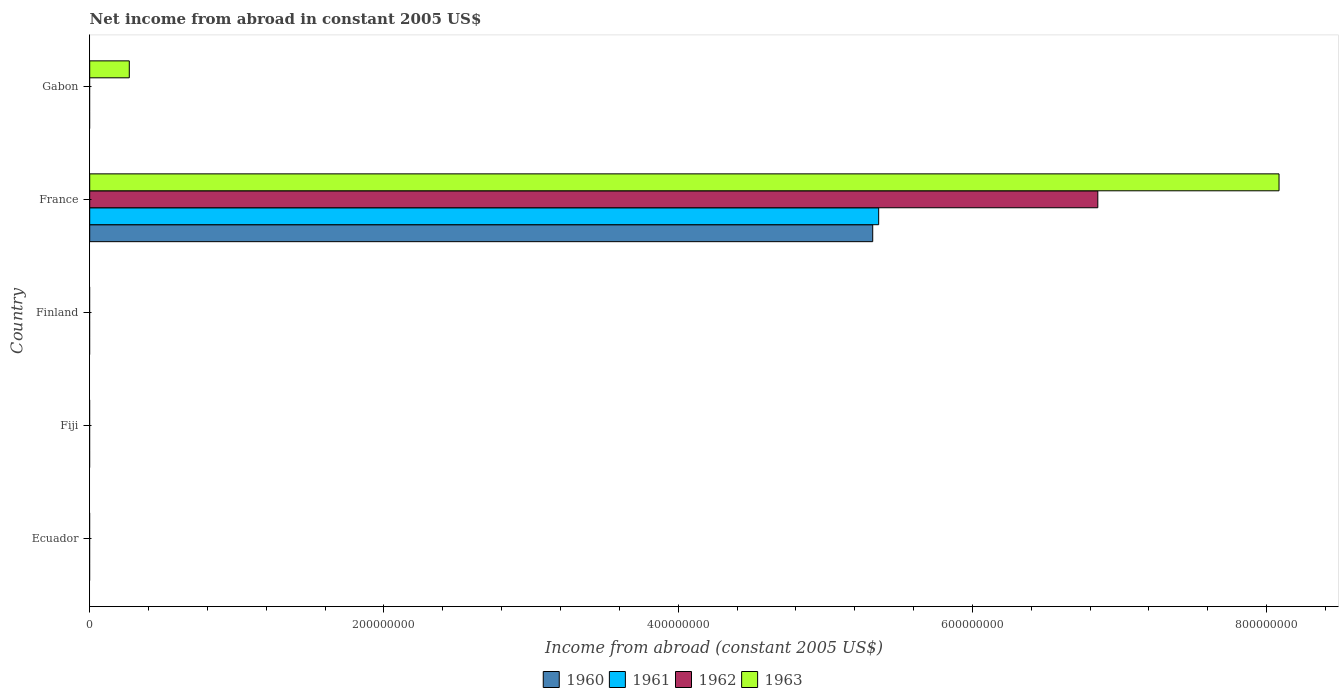How many bars are there on the 1st tick from the top?
Your response must be concise. 1. What is the label of the 4th group of bars from the top?
Your answer should be compact. Fiji. Across all countries, what is the maximum net income from abroad in 1963?
Ensure brevity in your answer.  8.08e+08. What is the total net income from abroad in 1960 in the graph?
Make the answer very short. 5.32e+08. What is the average net income from abroad in 1962 per country?
Offer a terse response. 1.37e+08. What is the difference between the net income from abroad in 1962 and net income from abroad in 1963 in France?
Your response must be concise. -1.23e+08. In how many countries, is the net income from abroad in 1963 greater than 520000000 US$?
Your answer should be compact. 1. What is the ratio of the net income from abroad in 1963 in France to that in Gabon?
Your answer should be compact. 30.04. What is the difference between the highest and the lowest net income from abroad in 1961?
Your answer should be very brief. 5.36e+08. In how many countries, is the net income from abroad in 1961 greater than the average net income from abroad in 1961 taken over all countries?
Give a very brief answer. 1. Is it the case that in every country, the sum of the net income from abroad in 1961 and net income from abroad in 1960 is greater than the sum of net income from abroad in 1962 and net income from abroad in 1963?
Offer a very short reply. No. Is it the case that in every country, the sum of the net income from abroad in 1962 and net income from abroad in 1963 is greater than the net income from abroad in 1960?
Your answer should be very brief. No. What is the difference between two consecutive major ticks on the X-axis?
Your response must be concise. 2.00e+08. Does the graph contain grids?
Offer a very short reply. No. Where does the legend appear in the graph?
Provide a succinct answer. Bottom center. How are the legend labels stacked?
Provide a short and direct response. Horizontal. What is the title of the graph?
Offer a terse response. Net income from abroad in constant 2005 US$. Does "1971" appear as one of the legend labels in the graph?
Your answer should be compact. No. What is the label or title of the X-axis?
Your answer should be compact. Income from abroad (constant 2005 US$). What is the label or title of the Y-axis?
Provide a short and direct response. Country. What is the Income from abroad (constant 2005 US$) of 1960 in Ecuador?
Make the answer very short. 0. What is the Income from abroad (constant 2005 US$) of 1963 in Fiji?
Provide a short and direct response. 0. What is the Income from abroad (constant 2005 US$) of 1960 in Finland?
Your answer should be compact. 0. What is the Income from abroad (constant 2005 US$) in 1961 in Finland?
Ensure brevity in your answer.  0. What is the Income from abroad (constant 2005 US$) of 1962 in Finland?
Give a very brief answer. 0. What is the Income from abroad (constant 2005 US$) in 1963 in Finland?
Provide a succinct answer. 0. What is the Income from abroad (constant 2005 US$) of 1960 in France?
Your answer should be compact. 5.32e+08. What is the Income from abroad (constant 2005 US$) of 1961 in France?
Provide a short and direct response. 5.36e+08. What is the Income from abroad (constant 2005 US$) in 1962 in France?
Offer a terse response. 6.85e+08. What is the Income from abroad (constant 2005 US$) in 1963 in France?
Your answer should be very brief. 8.08e+08. What is the Income from abroad (constant 2005 US$) in 1963 in Gabon?
Keep it short and to the point. 2.69e+07. Across all countries, what is the maximum Income from abroad (constant 2005 US$) in 1960?
Give a very brief answer. 5.32e+08. Across all countries, what is the maximum Income from abroad (constant 2005 US$) of 1961?
Provide a succinct answer. 5.36e+08. Across all countries, what is the maximum Income from abroad (constant 2005 US$) in 1962?
Your answer should be compact. 6.85e+08. Across all countries, what is the maximum Income from abroad (constant 2005 US$) of 1963?
Provide a short and direct response. 8.08e+08. Across all countries, what is the minimum Income from abroad (constant 2005 US$) of 1960?
Provide a succinct answer. 0. Across all countries, what is the minimum Income from abroad (constant 2005 US$) of 1961?
Give a very brief answer. 0. Across all countries, what is the minimum Income from abroad (constant 2005 US$) of 1962?
Provide a succinct answer. 0. What is the total Income from abroad (constant 2005 US$) of 1960 in the graph?
Make the answer very short. 5.32e+08. What is the total Income from abroad (constant 2005 US$) in 1961 in the graph?
Ensure brevity in your answer.  5.36e+08. What is the total Income from abroad (constant 2005 US$) of 1962 in the graph?
Your answer should be very brief. 6.85e+08. What is the total Income from abroad (constant 2005 US$) of 1963 in the graph?
Your answer should be very brief. 8.35e+08. What is the difference between the Income from abroad (constant 2005 US$) of 1963 in France and that in Gabon?
Offer a very short reply. 7.81e+08. What is the difference between the Income from abroad (constant 2005 US$) of 1960 in France and the Income from abroad (constant 2005 US$) of 1963 in Gabon?
Ensure brevity in your answer.  5.05e+08. What is the difference between the Income from abroad (constant 2005 US$) of 1961 in France and the Income from abroad (constant 2005 US$) of 1963 in Gabon?
Your answer should be very brief. 5.09e+08. What is the difference between the Income from abroad (constant 2005 US$) of 1962 in France and the Income from abroad (constant 2005 US$) of 1963 in Gabon?
Make the answer very short. 6.58e+08. What is the average Income from abroad (constant 2005 US$) in 1960 per country?
Offer a terse response. 1.06e+08. What is the average Income from abroad (constant 2005 US$) in 1961 per country?
Your answer should be compact. 1.07e+08. What is the average Income from abroad (constant 2005 US$) in 1962 per country?
Your answer should be very brief. 1.37e+08. What is the average Income from abroad (constant 2005 US$) of 1963 per country?
Your answer should be compact. 1.67e+08. What is the difference between the Income from abroad (constant 2005 US$) in 1960 and Income from abroad (constant 2005 US$) in 1961 in France?
Offer a terse response. -4.05e+06. What is the difference between the Income from abroad (constant 2005 US$) in 1960 and Income from abroad (constant 2005 US$) in 1962 in France?
Ensure brevity in your answer.  -1.53e+08. What is the difference between the Income from abroad (constant 2005 US$) of 1960 and Income from abroad (constant 2005 US$) of 1963 in France?
Provide a short and direct response. -2.76e+08. What is the difference between the Income from abroad (constant 2005 US$) in 1961 and Income from abroad (constant 2005 US$) in 1962 in France?
Keep it short and to the point. -1.49e+08. What is the difference between the Income from abroad (constant 2005 US$) in 1961 and Income from abroad (constant 2005 US$) in 1963 in France?
Offer a terse response. -2.72e+08. What is the difference between the Income from abroad (constant 2005 US$) of 1962 and Income from abroad (constant 2005 US$) of 1963 in France?
Make the answer very short. -1.23e+08. What is the ratio of the Income from abroad (constant 2005 US$) of 1963 in France to that in Gabon?
Offer a terse response. 30.04. What is the difference between the highest and the lowest Income from abroad (constant 2005 US$) of 1960?
Your answer should be very brief. 5.32e+08. What is the difference between the highest and the lowest Income from abroad (constant 2005 US$) in 1961?
Provide a short and direct response. 5.36e+08. What is the difference between the highest and the lowest Income from abroad (constant 2005 US$) in 1962?
Your answer should be compact. 6.85e+08. What is the difference between the highest and the lowest Income from abroad (constant 2005 US$) of 1963?
Make the answer very short. 8.08e+08. 